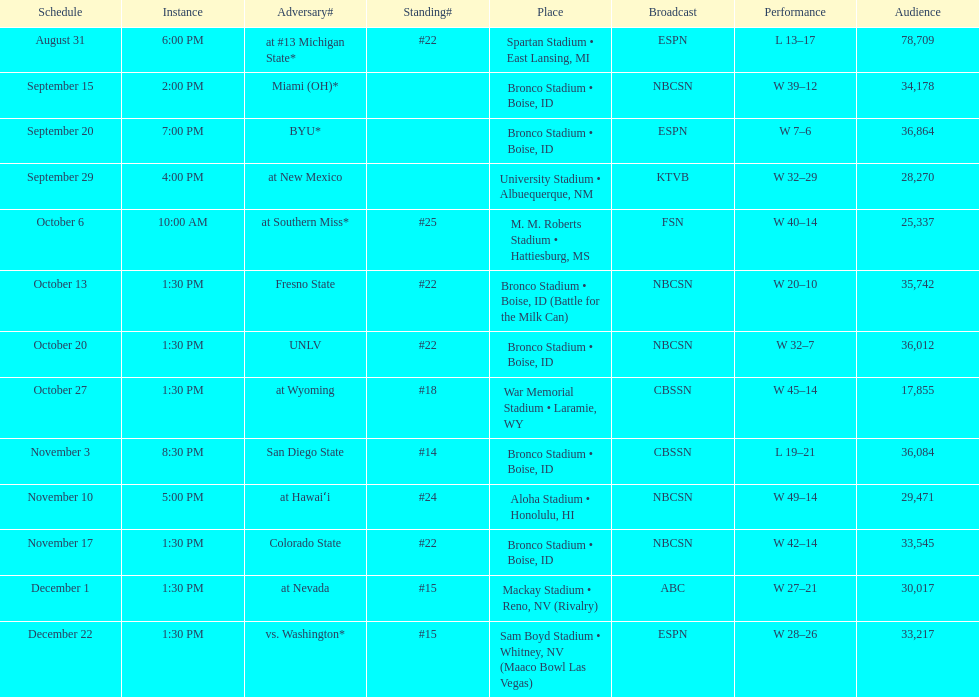What was the point tally for miami (oh) when they played against the broncos? 12. 